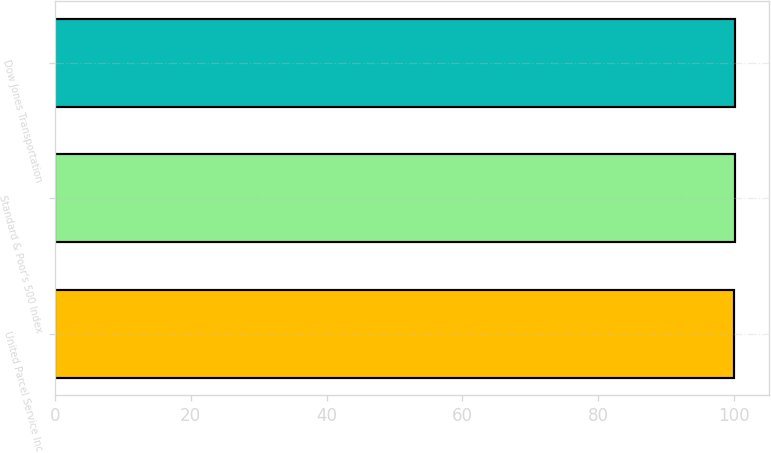Convert chart to OTSL. <chart><loc_0><loc_0><loc_500><loc_500><bar_chart><fcel>United Parcel Service Inc<fcel>Standard & Poor's 500 Index<fcel>Dow Jones Transportation<nl><fcel>100<fcel>100.1<fcel>100.2<nl></chart> 